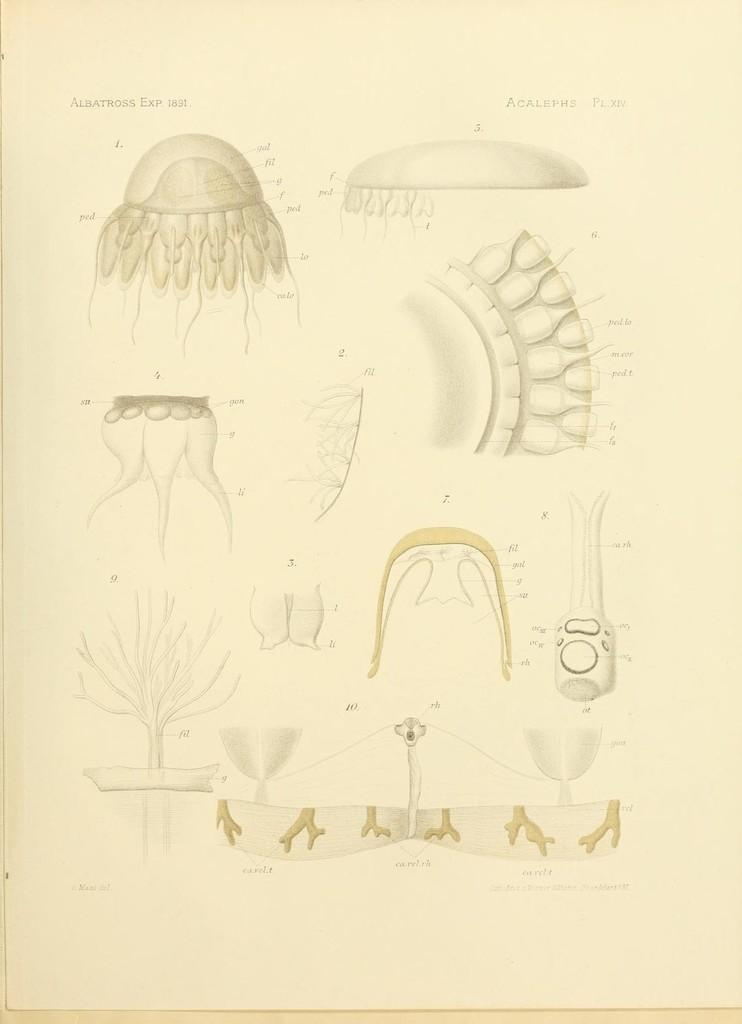What is on the cream color paper in the image? There are pictures on the cream color paper in the image. What else can be seen on the paper in the image? There is writing on the paper in the image. How many ants can be seen crawling on the paper in the image? There are no ants present in the image; it only features pictures and writing on the cream color paper. What type of form is being filled out in the image? There is no form present in the image; it only features pictures and writing on the cream color paper. 